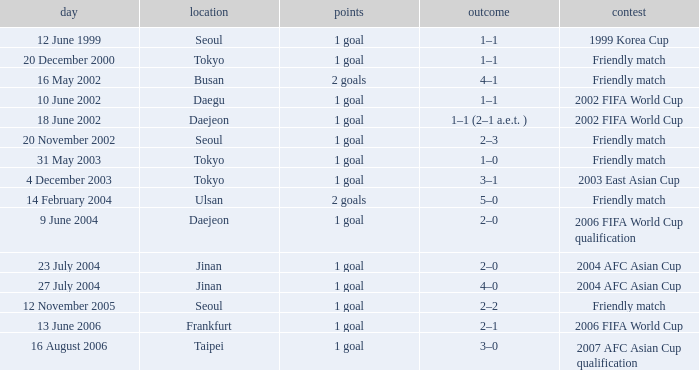What was the score of the game played on 16 August 2006? 1 goal. 